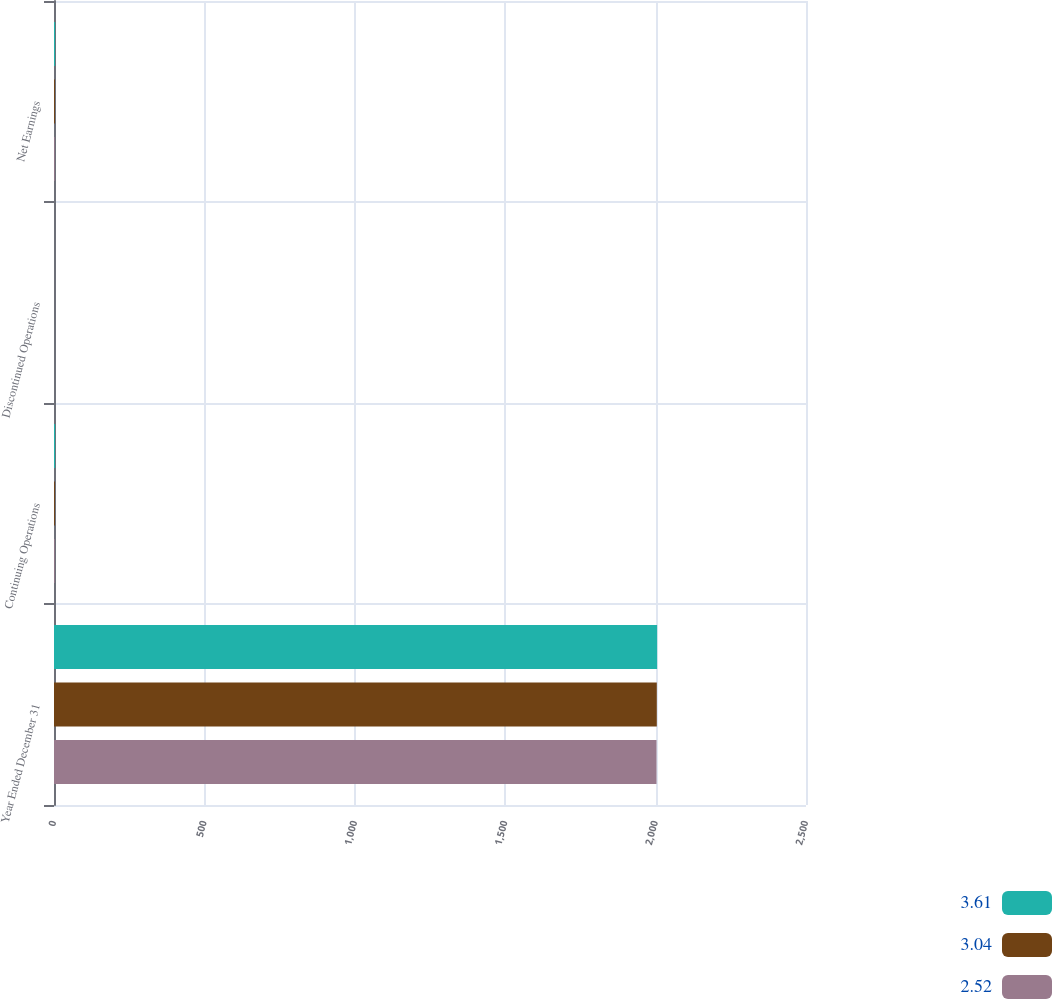Convert chart. <chart><loc_0><loc_0><loc_500><loc_500><stacked_bar_chart><ecel><fcel>Year Ended December 31<fcel>Continuing Operations<fcel>Discontinued Operations<fcel>Net Earnings<nl><fcel>3.61<fcel>2005<fcel>3.66<fcel>0.02<fcel>3.64<nl><fcel>3.04<fcel>2004<fcel>3.02<fcel>0.05<fcel>3.07<nl><fcel>2.52<fcel>2003<fcel>2.48<fcel>0.06<fcel>2.54<nl></chart> 